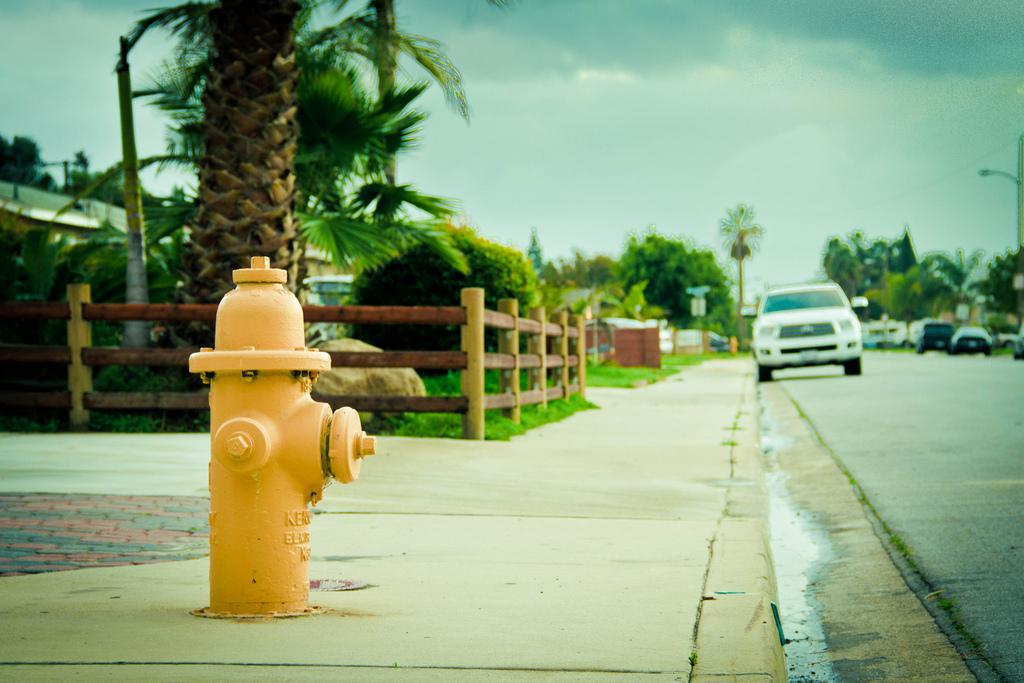Question: when was this picture taken?
Choices:
A. At night.
B. At noon.
C. At dusk.
D. During the day.
Answer with the letter. Answer: D Question: what do the clouds make you think?
Choices:
A. That it's a beautiful day, weather-wise.
B. It may storm later.
C. About going for a swim.
D. That the rain is going to stop soon.
Answer with the letter. Answer: B Question: what is behind the fire hydrant?
Choices:
A. A house.
B. A church.
C. A business.
D. A tree.
Answer with the letter. Answer: A Question: where are white car facing?
Choices:
A. To the left.
B. To the right.
C. Forwards.
D. Our way.
Answer with the letter. Answer: D Question: what is in sky?
Choices:
A. Birds.
B. Airplanes.
C. Helicopters.
D. Clouds.
Answer with the letter. Answer: D Question: what color is grass?
Choices:
A. Yellow.
B. Green.
C. Brown.
D. Black.
Answer with the letter. Answer: B Question: who is on sidewalk?
Choices:
A. Nobody.
B. Dog.
C. Cat.
D. Man.
Answer with the letter. Answer: A Question: what is in background?
Choices:
A. Trees.
B. Brown fence.
C. Dog.
D. Diamond ring.
Answer with the letter. Answer: B Question: what is shown on left?
Choices:
A. Diamonds.
B. Flags.
C. Kites.
D. Red and black bricks.
Answer with the letter. Answer: D Question: what color hue does picture have?
Choices:
A. Yellow.
B. Green.
C. Blue.
D. Red.
Answer with the letter. Answer: B Question: what is part of the sidewalk?
Choices:
A. Brick pattern.
B. Gravel.
C. Dirt.
D. Concrete.
Answer with the letter. Answer: A Question: what is parked on street?
Choices:
A. Bike.
B. Cars.
C. Motorcycle.
D. Wagon.
Answer with the letter. Answer: B Question: what sits on sidewalk?
Choices:
A. Cat.
B. Yellow fire hydrant.
C. Kids.
D. Dog.
Answer with the letter. Answer: B Question: where was this photo taken?
Choices:
A. On a sidewalk.
B. At the shopping mall.
C. At the new art gallery.
D. At the farmer's market.
Answer with the letter. Answer: A Question: what is behind the fire hydrant?
Choices:
A. A fence.
B. A sidewalk.
C. A building.
D. A tree.
Answer with the letter. Answer: A Question: how is the truck in the background parked?
Choices:
A. Along the curb.
B. In the middle of the street.
C. In the parking lot.
D. It is parallel parked.
Answer with the letter. Answer: D Question: where was this picture taken?
Choices:
A. By the buildings.
B. Near the fence.
C. On a sidewalk.
D. Near the entrance.
Answer with the letter. Answer: C 